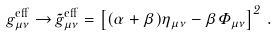Convert formula to latex. <formula><loc_0><loc_0><loc_500><loc_500>g _ { \mu \nu } ^ { \text {eff} } \to \tilde { g } _ { \mu \nu } ^ { \text {eff} } = \left [ ( \alpha + \beta ) \eta _ { \mu \nu } - \beta \Phi _ { \mu \nu } \right ] ^ { 2 } \, .</formula> 